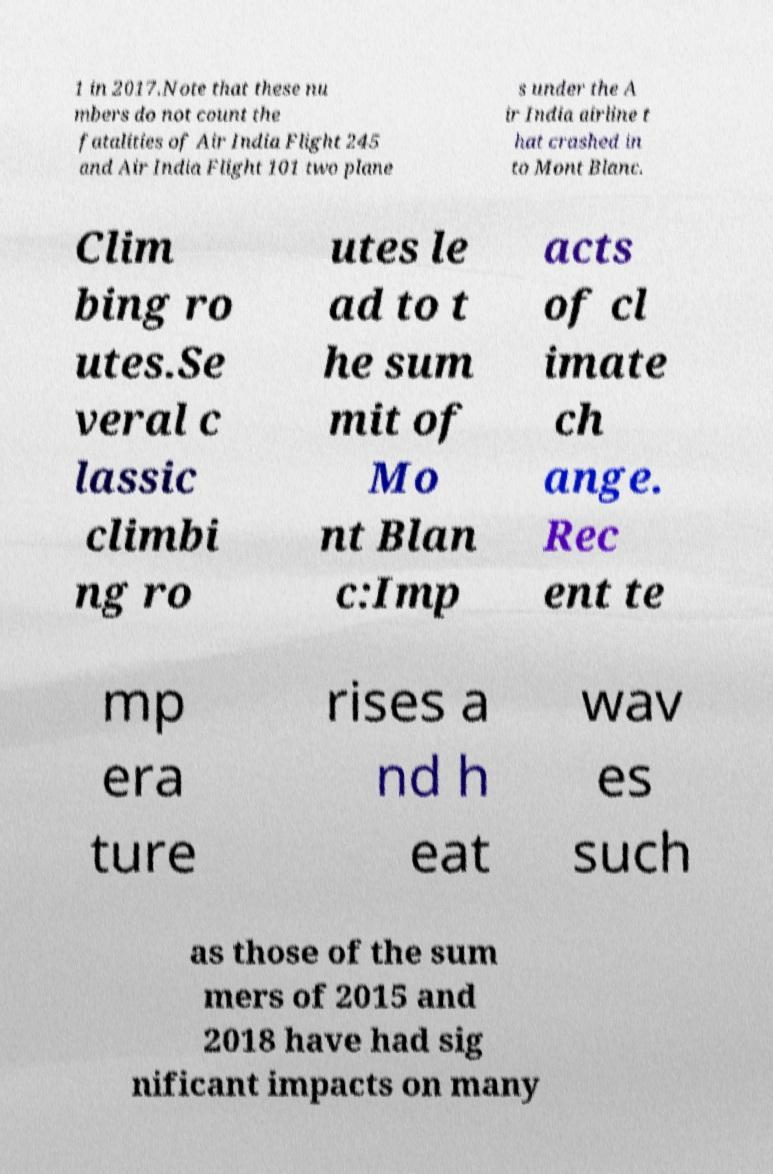Can you accurately transcribe the text from the provided image for me? 1 in 2017.Note that these nu mbers do not count the fatalities of Air India Flight 245 and Air India Flight 101 two plane s under the A ir India airline t hat crashed in to Mont Blanc. Clim bing ro utes.Se veral c lassic climbi ng ro utes le ad to t he sum mit of Mo nt Blan c:Imp acts of cl imate ch ange. Rec ent te mp era ture rises a nd h eat wav es such as those of the sum mers of 2015 and 2018 have had sig nificant impacts on many 